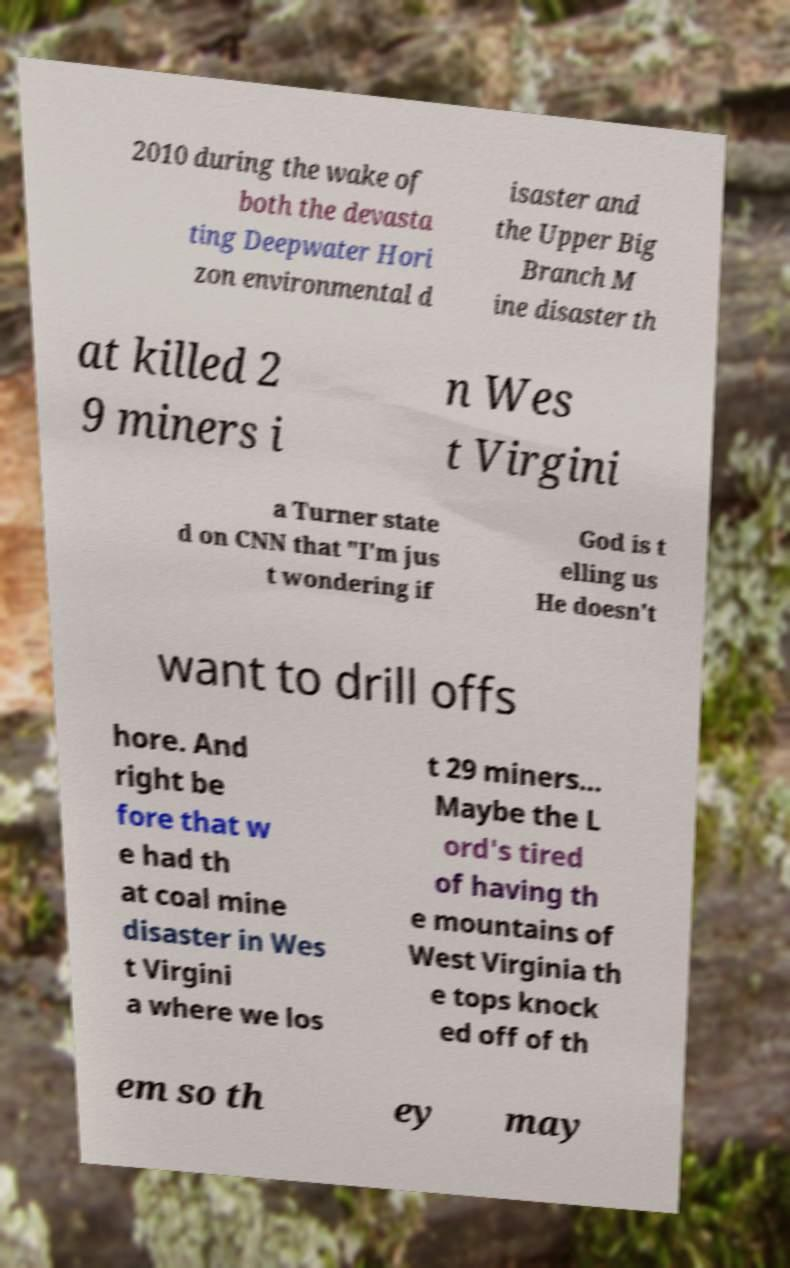Can you read and provide the text displayed in the image?This photo seems to have some interesting text. Can you extract and type it out for me? 2010 during the wake of both the devasta ting Deepwater Hori zon environmental d isaster and the Upper Big Branch M ine disaster th at killed 2 9 miners i n Wes t Virgini a Turner state d on CNN that "I'm jus t wondering if God is t elling us He doesn't want to drill offs hore. And right be fore that w e had th at coal mine disaster in Wes t Virgini a where we los t 29 miners... Maybe the L ord's tired of having th e mountains of West Virginia th e tops knock ed off of th em so th ey may 